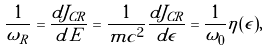<formula> <loc_0><loc_0><loc_500><loc_500>\frac { 1 } { { \omega } _ { R } } = \frac { d J _ { C R } } { d \tilde { E } } = \frac { 1 } { m c ^ { 2 } } \frac { d J _ { C R } } { d \epsilon } = \frac { 1 } { { \omega } _ { 0 } } \eta ( \epsilon ) ,</formula> 